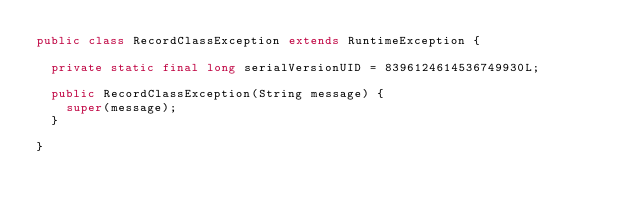Convert code to text. <code><loc_0><loc_0><loc_500><loc_500><_Java_>public class RecordClassException extends RuntimeException {

	private static final long serialVersionUID = 8396124614536749930L;

	public RecordClassException(String message) {
		super(message);
	}

}
</code> 